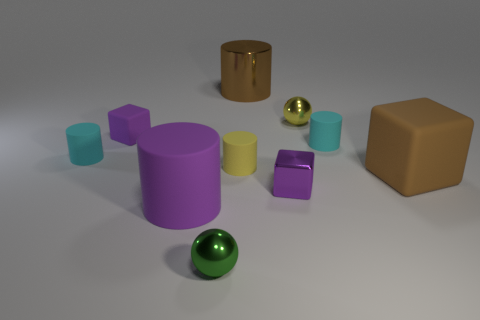Subtract 2 cylinders. How many cylinders are left? 3 Subtract all gray cylinders. Subtract all gray blocks. How many cylinders are left? 5 Subtract all balls. How many objects are left? 8 Add 1 large brown matte balls. How many large brown matte balls exist? 1 Subtract 1 brown cylinders. How many objects are left? 9 Subtract all big brown rubber balls. Subtract all large matte blocks. How many objects are left? 9 Add 8 tiny purple cubes. How many tiny purple cubes are left? 10 